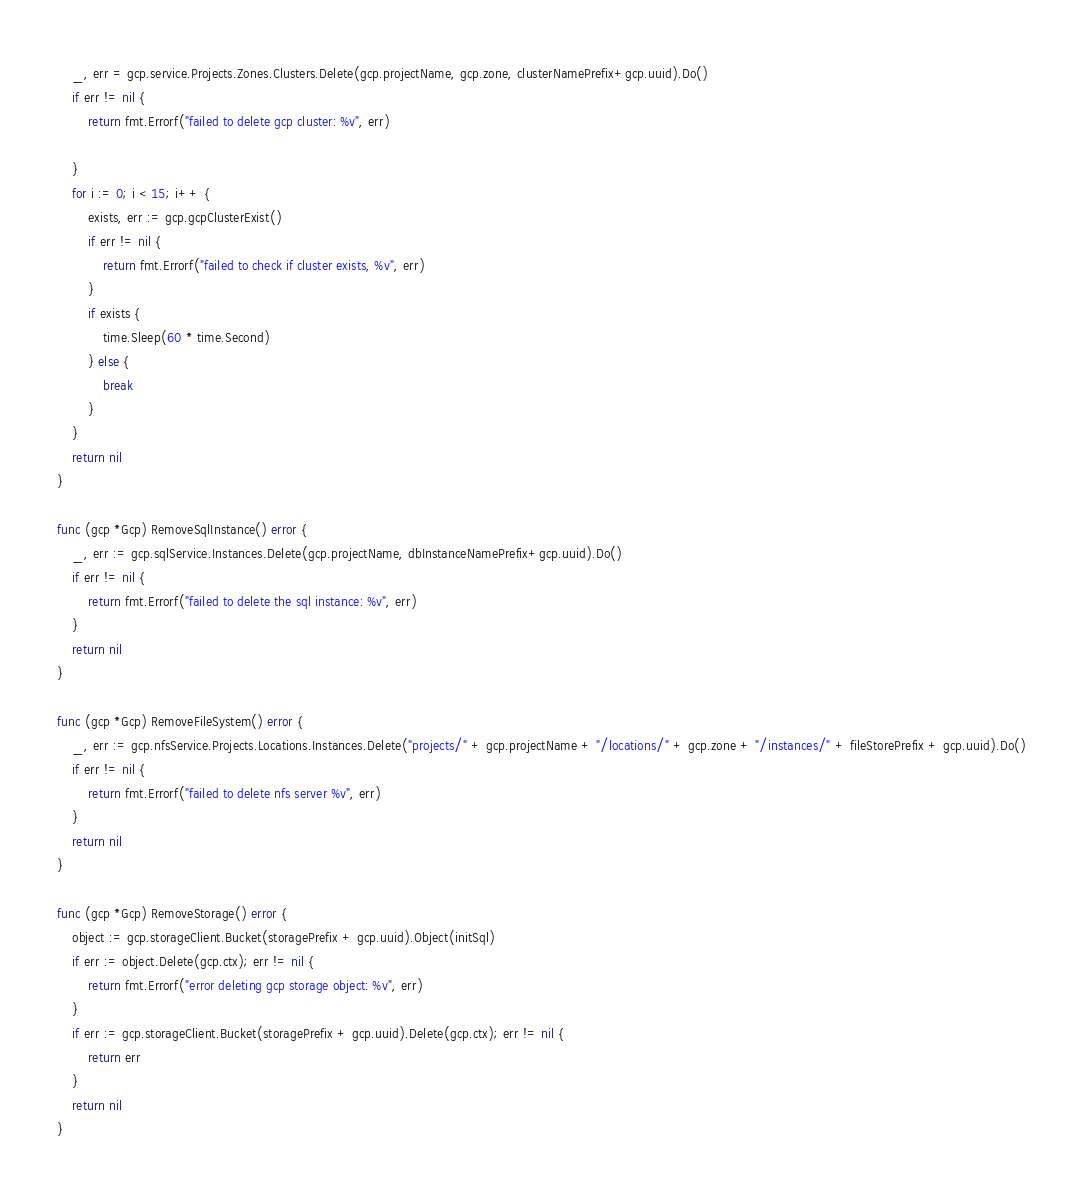Convert code to text. <code><loc_0><loc_0><loc_500><loc_500><_Go_>	_, err = gcp.service.Projects.Zones.Clusters.Delete(gcp.projectName, gcp.zone, clusterNamePrefix+gcp.uuid).Do()
	if err != nil {
		return fmt.Errorf("failed to delete gcp cluster: %v", err)

	}
	for i := 0; i < 15; i++ {
		exists, err := gcp.gcpClusterExist()
		if err != nil {
			return fmt.Errorf("failed to check if cluster exists, %v", err)
		}
		if exists {
			time.Sleep(60 * time.Second)
		} else {
			break
		}
	}
	return nil
}

func (gcp *Gcp) RemoveSqlInstance() error {
	_, err := gcp.sqlService.Instances.Delete(gcp.projectName, dbInstanceNamePrefix+gcp.uuid).Do()
	if err != nil {
		return fmt.Errorf("failed to delete the sql instance: %v", err)
	}
	return nil
}

func (gcp *Gcp) RemoveFileSystem() error {
	_, err := gcp.nfsService.Projects.Locations.Instances.Delete("projects/" + gcp.projectName + "/locations/" + gcp.zone + "/instances/" + fileStorePrefix + gcp.uuid).Do()
	if err != nil {
		return fmt.Errorf("failed to delete nfs server %v", err)
	}
	return nil
}

func (gcp *Gcp) RemoveStorage() error {
	object := gcp.storageClient.Bucket(storagePrefix + gcp.uuid).Object(initSql)
	if err := object.Delete(gcp.ctx); err != nil {
		return fmt.Errorf("error deleting gcp storage object: %v", err)
	}
	if err := gcp.storageClient.Bucket(storagePrefix + gcp.uuid).Delete(gcp.ctx); err != nil {
		return err
	}
	return nil
}
</code> 